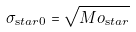<formula> <loc_0><loc_0><loc_500><loc_500>\sigma _ { \mathrm s t a r 0 } = \sqrt { M o _ { \mathrm s t a r } }</formula> 